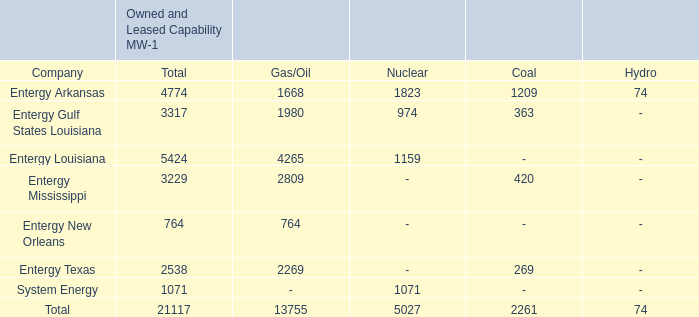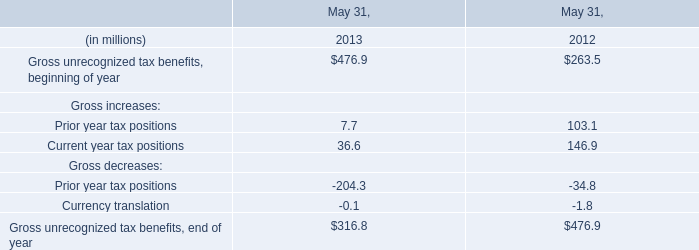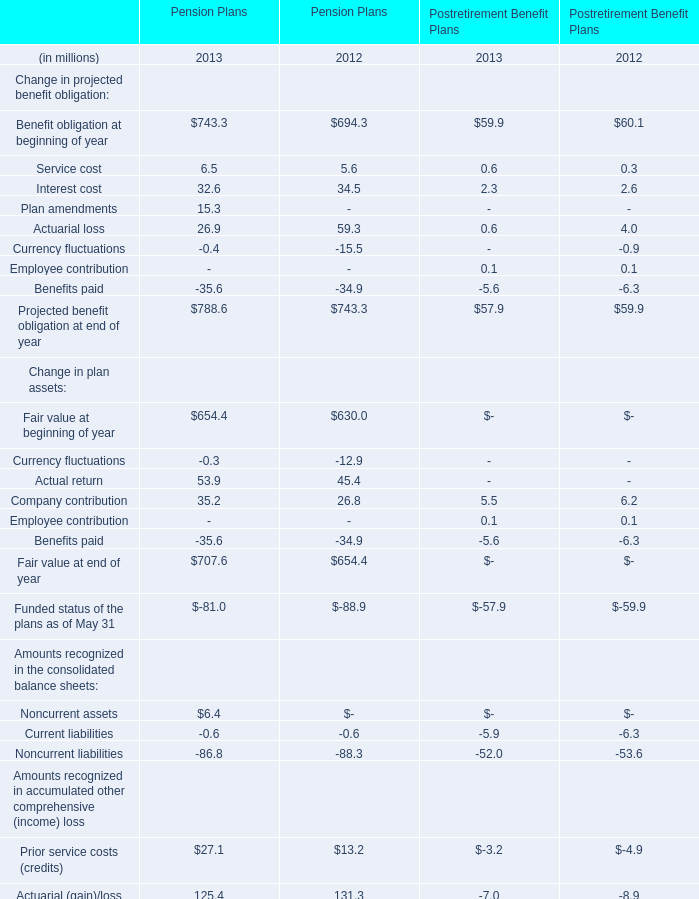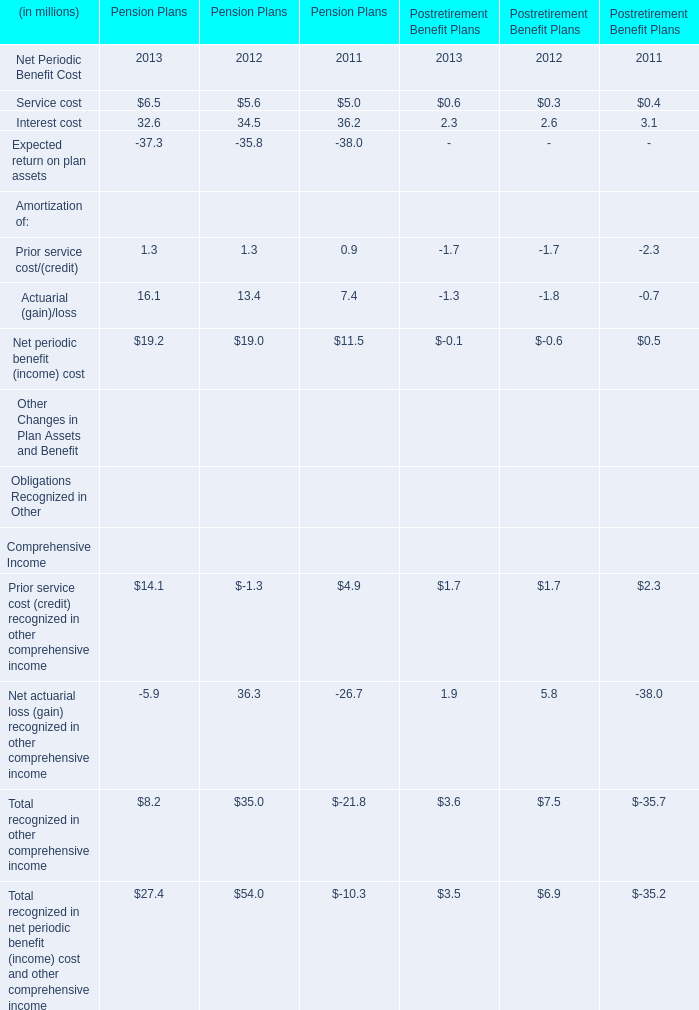What's the average of Interest cost for Pension Plans? (in million) 
Computations: (((32.6 + 34.5) + 36.2) / 3)
Answer: 34.43333. 